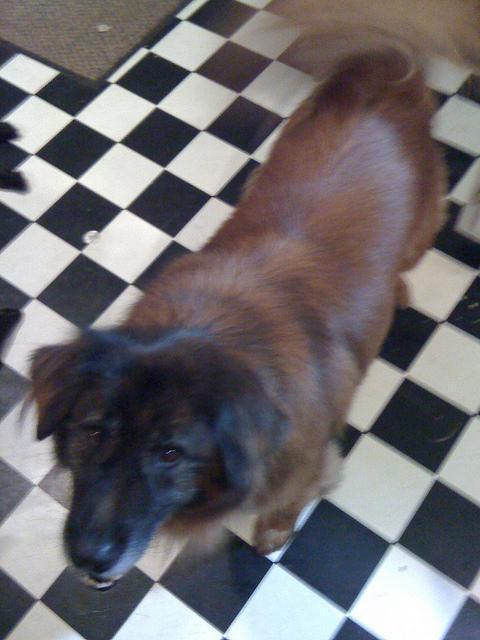How many women in the picture?
Give a very brief answer. 0. 